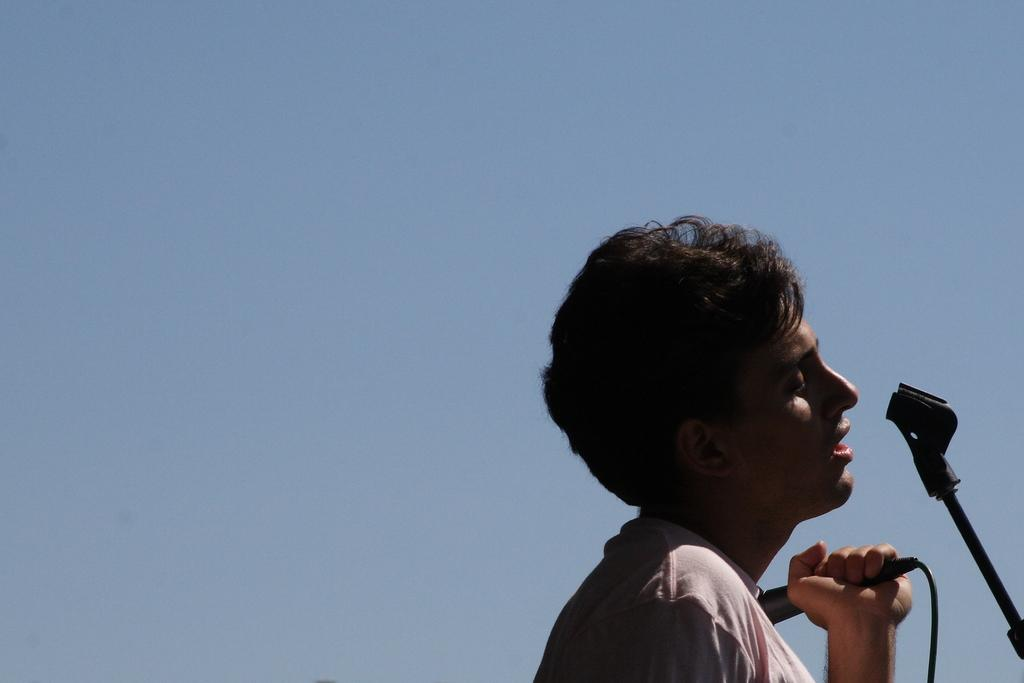Who or what is the main subject of the image? There is a person in the image. What is the person holding in their hand? The person is holding a microphone in their hand. What can be seen behind the person in the image? The person is standing in front of a stand. What thrilling activity is the person participating in with their daughter in the image? There is no indication of a daughter or any thrilling activity in the image; it only shows a person holding a microphone and standing in front of a stand. 